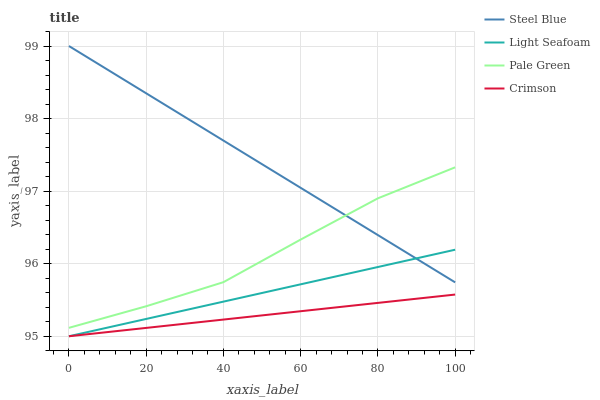Does Pale Green have the minimum area under the curve?
Answer yes or no. No. Does Pale Green have the maximum area under the curve?
Answer yes or no. No. Is Pale Green the smoothest?
Answer yes or no. No. Is Light Seafoam the roughest?
Answer yes or no. No. Does Pale Green have the lowest value?
Answer yes or no. No. Does Pale Green have the highest value?
Answer yes or no. No. Is Crimson less than Steel Blue?
Answer yes or no. Yes. Is Pale Green greater than Light Seafoam?
Answer yes or no. Yes. Does Crimson intersect Steel Blue?
Answer yes or no. No. 